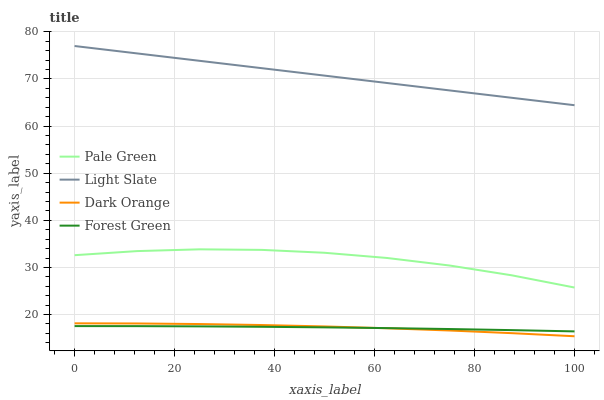Does Forest Green have the minimum area under the curve?
Answer yes or no. Yes. Does Light Slate have the maximum area under the curve?
Answer yes or no. Yes. Does Dark Orange have the minimum area under the curve?
Answer yes or no. No. Does Dark Orange have the maximum area under the curve?
Answer yes or no. No. Is Light Slate the smoothest?
Answer yes or no. Yes. Is Pale Green the roughest?
Answer yes or no. Yes. Is Dark Orange the smoothest?
Answer yes or no. No. Is Dark Orange the roughest?
Answer yes or no. No. Does Dark Orange have the lowest value?
Answer yes or no. Yes. Does Forest Green have the lowest value?
Answer yes or no. No. Does Light Slate have the highest value?
Answer yes or no. Yes. Does Dark Orange have the highest value?
Answer yes or no. No. Is Forest Green less than Pale Green?
Answer yes or no. Yes. Is Pale Green greater than Dark Orange?
Answer yes or no. Yes. Does Dark Orange intersect Forest Green?
Answer yes or no. Yes. Is Dark Orange less than Forest Green?
Answer yes or no. No. Is Dark Orange greater than Forest Green?
Answer yes or no. No. Does Forest Green intersect Pale Green?
Answer yes or no. No. 